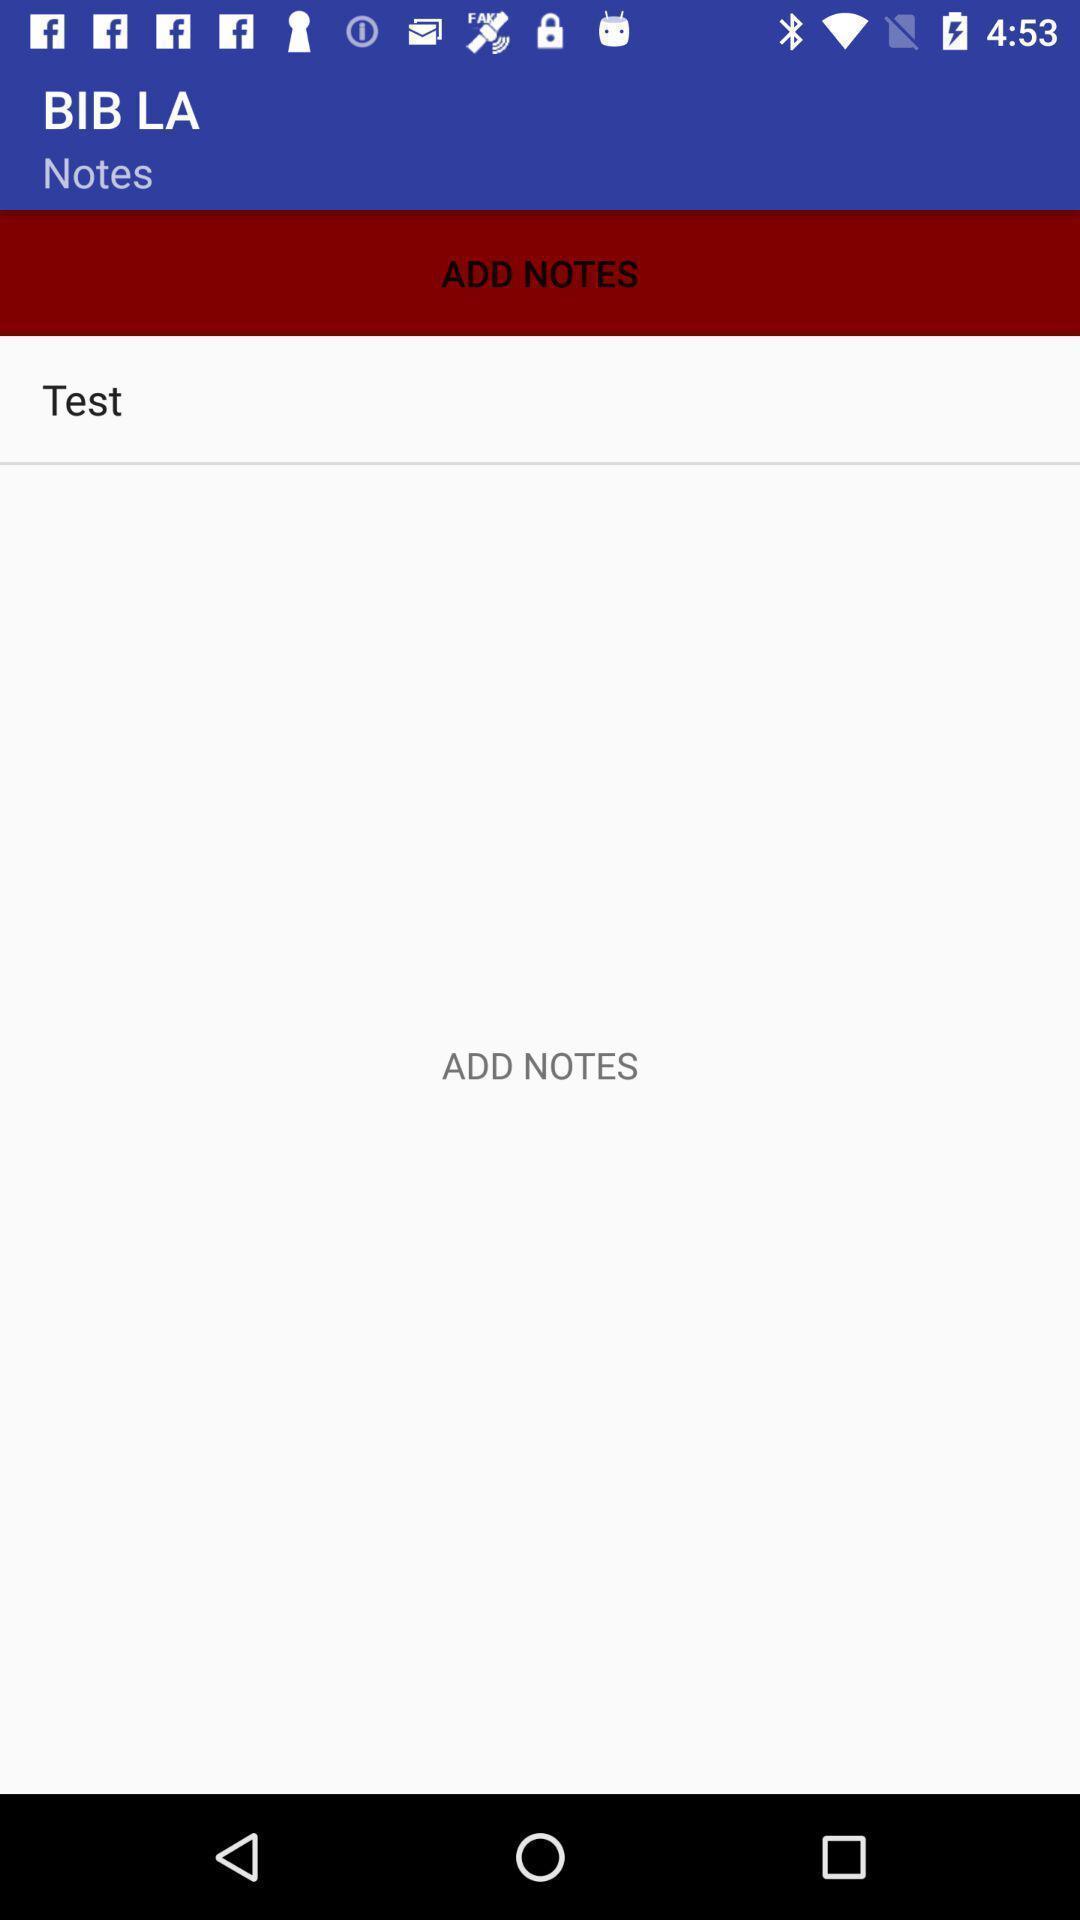Give me a summary of this screen capture. Page displays to add a note in application. 